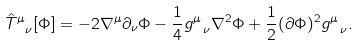<formula> <loc_0><loc_0><loc_500><loc_500>{ \hat { T } } ^ { \mu } _ { \ \nu } [ \Phi ] = - 2 \nabla ^ { \mu } \partial _ { \nu } \Phi - { \frac { 1 } { 4 } } g ^ { \mu } _ { \ \nu } \nabla ^ { 2 } \Phi + { \frac { 1 } { 2 } } ( \partial \Phi ) ^ { 2 } g ^ { \mu } _ { \ \nu } .</formula> 